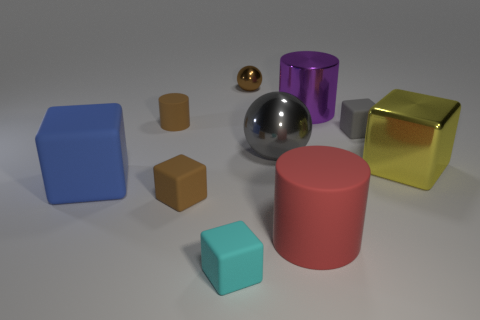Subtract all metallic cylinders. How many cylinders are left? 2 Subtract all purple cylinders. How many cylinders are left? 2 Subtract all cylinders. How many objects are left? 7 Subtract 4 cubes. How many cubes are left? 1 Subtract all cyan spheres. Subtract all purple cylinders. How many spheres are left? 2 Subtract all large red rubber cylinders. Subtract all large shiny balls. How many objects are left? 8 Add 2 red objects. How many red objects are left? 3 Add 9 tiny rubber balls. How many tiny rubber balls exist? 9 Subtract 0 gray cylinders. How many objects are left? 10 